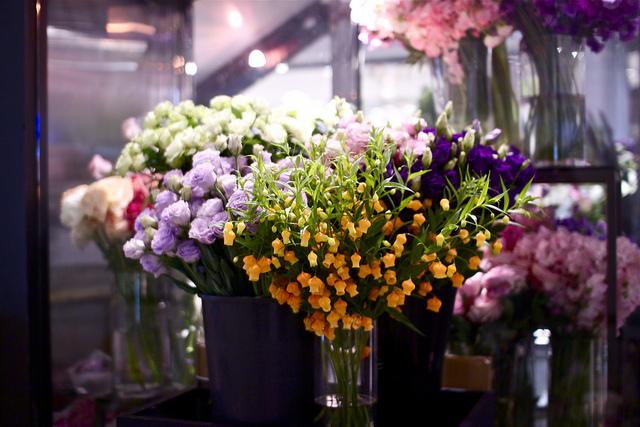What color flowers are on the top right?
Be succinct. Purple. Is the area lit?
Answer briefly. Yes. Where was this shot at?
Keep it brief. Florist. Are the vases identical?
Concise answer only. No. 